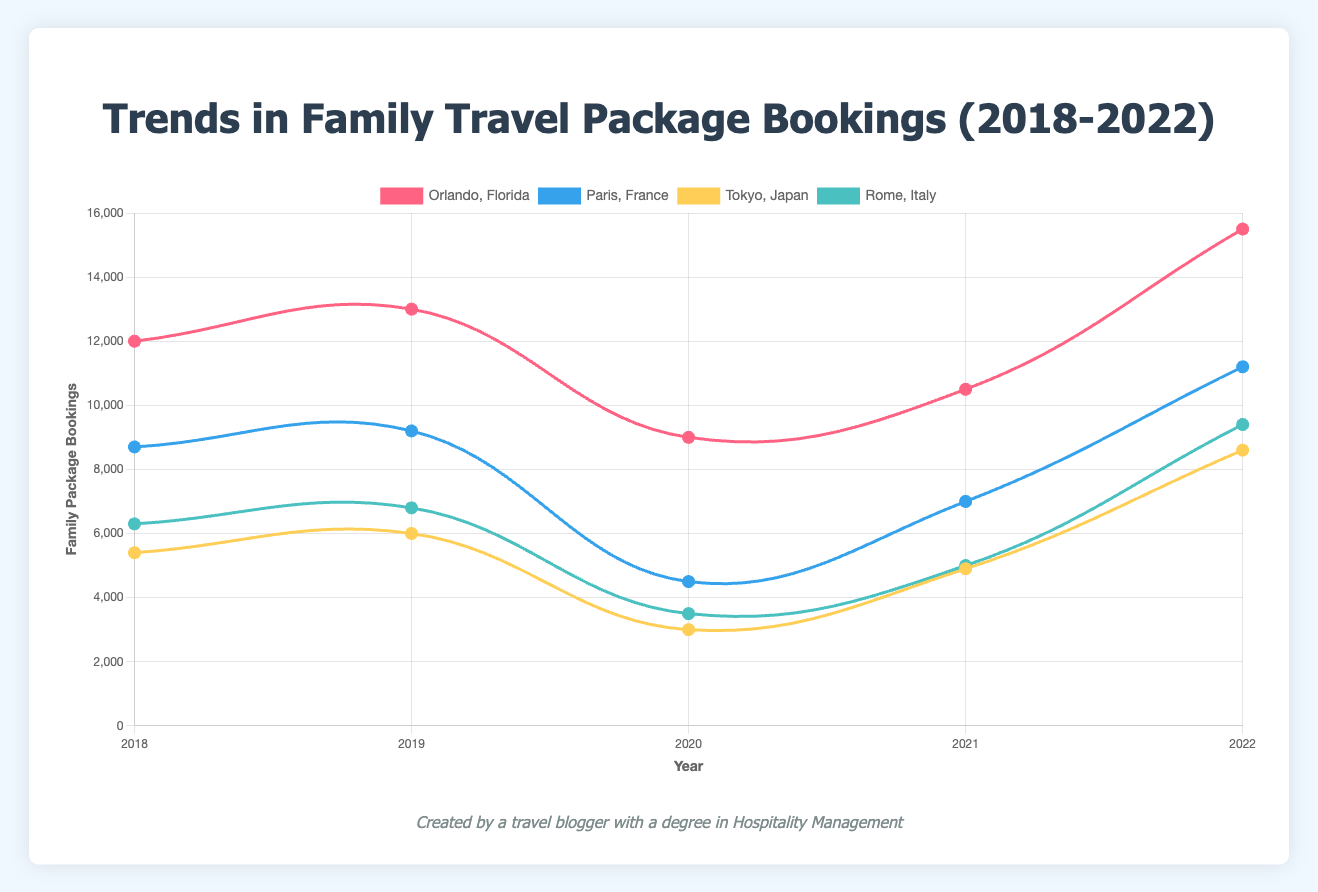What's the trend in family package bookings for Orlando, Florida from 2018 to 2022? From the figure, observe the data points for Orlando, Florida over the years: 12000 (2018), 13000 (2019), 9000 (2020), 10500 (2021), 15500 (2022). There is an overall increasing trend with a dip in 2020.
Answer: Overall increasing trend Which destination had the highest number of family package bookings in 2022? Compare the data points for each destination in 2022: Orlando, Florida (15500), Paris, France (11200), Tokyo, Japan (8600), Rome, Italy (9400). Orlando, Florida has the highest number of bookings.
Answer: Orlando, Florida How did the family package bookings for Paris, France change from 2019 to 2020? Check the data points for Paris, France in 2019 (9200) and 2020 (4500). The bookings decreased from 9200 to 4500. Calculate the difference: 9200 - 4500 = 4700 decrease.
Answer: Decreased by 4700 Which destination showed the most improvement in family package bookings from 2021 to 2022? Examine the changes for each destination: Orlando, Florida (10500 to 15500, +5000), Paris, France (7000 to 11200, +4200), Tokyo, Japan (4900 to 8600, +3700), Rome, Italy (5000 to 9400, +4400). Orlando, Florida showed the most improvement.
Answer: Orlando, Florida In 2020, which destination had the lowest number of family package bookings? Compare the data points for each destination in 2020: Orlando, Florida (9000), Paris, France (4500), Tokyo, Japan (3000), Rome, Italy (3500). Tokyo, Japan had the lowest number of bookings.
Answer: Tokyo, Japan By how much did the family package bookings for Tokyo, Japan increase from 2020 to 2021, and from 2021 to 2022? From the figure, Tokyo, Japan had the bookings: 2020 (3000), 2021 (4900), 2022 (8600). Calculate the increases: 2021 - 2020 (4900 - 3000 = 1900), 2022 - 2021 (8600 - 4900 = 3700).
Answer: 1900 and 3700 What is the average number of family package bookings for Rome, Italy over the five years period? Sum the bookings over five years: 6300 (2018), 6800 (2019), 3500 (2020), 5000 (2021), 9400 (2022). Sum = 6300 + 6800 + 3500 + 5000 + 9400 = 31000. Average = 31000 / 5 = 6200.
Answer: 6200 Which year had the lowest overall family package bookings for all destinations combined? Sum the bookings for each year: 2018 (12000+8700+5400+6300=32400), 2019 (13000+9200+6000+6800=35000), 2020 (9000+4500+3000+3500=20000), 2021 (10500+7000+4900+5000=27400), 2022 (15500+11200+8600+9400=44700). 2020 had the lowest sum.
Answer: 2020 Which destination had the most consistent trend (smallest fluctuations) in the number of family package bookings over the five years? Observe the changes and fluctuations for each destination. Orlando, Florida showed the largest fluctuations, while Paris, France showed a steady decline with a recovery post-2020, Rome, Italy shows smaller changes year-on-year compared to others.
Answer: Rome, Italy 